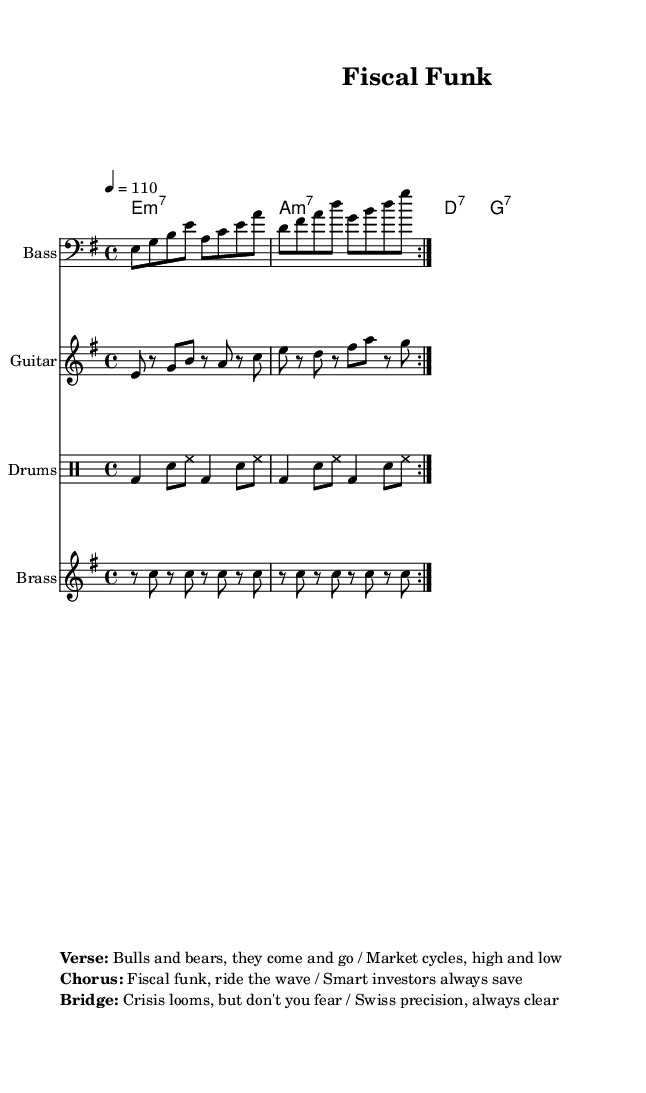What is the key signature of this music? The key signature is indicated by the ‘\key e \minor’ line, which shows that there are no sharps or flats, and the piece is in E minor.
Answer: E minor What is the time signature of the piece? The time signature is shown as ‘\time 4/4’, which means there are four beats per measure and a quarter note receives one beat.
Answer: 4/4 What is the tempo marking of the composition? The tempo is indicated by ‘\tempo 4 = 110’, meaning the piece should be played at 110 beats per minute, with each beat a quarter note.
Answer: 110 How many measures are repeated in the bass line? The bass line includes the ‘\repeat volta 2’ directive, which indicates that it is played two times in total.
Answer: 2 What type of chords are used in the keyboard part? The keyboard part indicates ‘e1:m7’ for an E minor 7 chord, followed by ‘a:m7’ and ‘d:7’, and finally ‘g:7’, showing it uses different seventh chords consistent with funk music.
Answer: Seventh chords What thematic element is reflected in the lyrics of the song? The lyrics reference financial concepts such as "Bulls and bears", "Market cycles", and "Crisis looms", which tie the economic commentary to the funk genre, emphasizing themes relevant to investors and markets.
Answer: Financial themes How does the drum pattern enhance the funk style? The drum pattern with steady bass and snare hits are characteristic of funk, providing a strong rhythmic foundation that drives the piece, which is a critical element in funk music.
Answer: Strong rhythmic foundation 